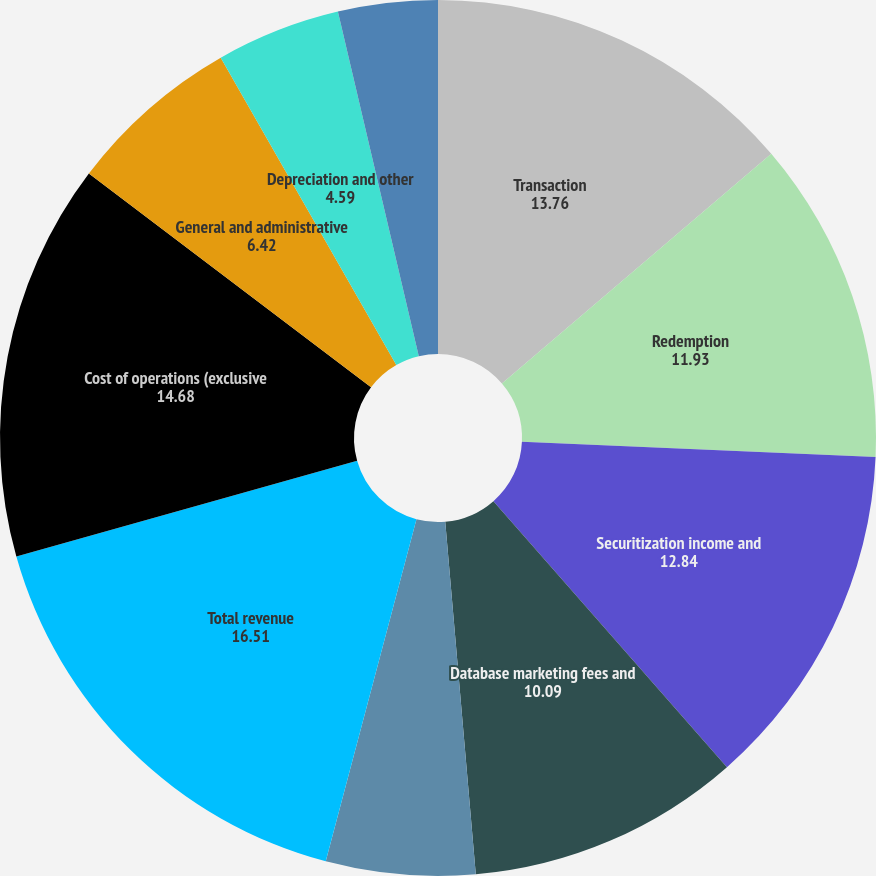Convert chart. <chart><loc_0><loc_0><loc_500><loc_500><pie_chart><fcel>Transaction<fcel>Redemption<fcel>Securitization income and<fcel>Database marketing fees and<fcel>Other revenue<fcel>Total revenue<fcel>Cost of operations (exclusive<fcel>General and administrative<fcel>Depreciation and other<fcel>Amortization of purchased<nl><fcel>13.76%<fcel>11.93%<fcel>12.84%<fcel>10.09%<fcel>5.5%<fcel>16.51%<fcel>14.68%<fcel>6.42%<fcel>4.59%<fcel>3.67%<nl></chart> 